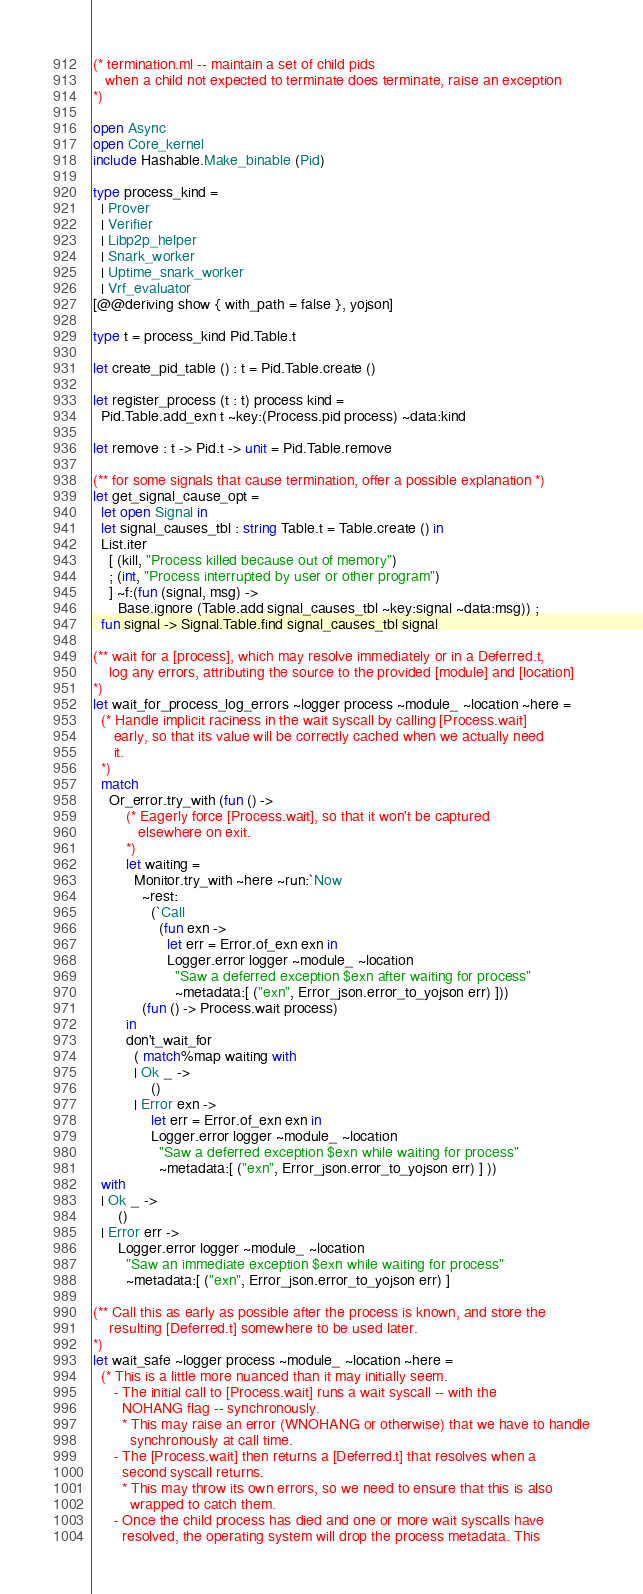Convert code to text. <code><loc_0><loc_0><loc_500><loc_500><_OCaml_>(* termination.ml -- maintain a set of child pids
   when a child not expected to terminate does terminate, raise an exception
*)

open Async
open Core_kernel
include Hashable.Make_binable (Pid)

type process_kind =
  | Prover
  | Verifier
  | Libp2p_helper
  | Snark_worker
  | Uptime_snark_worker
  | Vrf_evaluator
[@@deriving show { with_path = false }, yojson]

type t = process_kind Pid.Table.t

let create_pid_table () : t = Pid.Table.create ()

let register_process (t : t) process kind =
  Pid.Table.add_exn t ~key:(Process.pid process) ~data:kind

let remove : t -> Pid.t -> unit = Pid.Table.remove

(** for some signals that cause termination, offer a possible explanation *)
let get_signal_cause_opt =
  let open Signal in
  let signal_causes_tbl : string Table.t = Table.create () in
  List.iter
    [ (kill, "Process killed because out of memory")
    ; (int, "Process interrupted by user or other program")
    ] ~f:(fun (signal, msg) ->
      Base.ignore (Table.add signal_causes_tbl ~key:signal ~data:msg)) ;
  fun signal -> Signal.Table.find signal_causes_tbl signal

(** wait for a [process], which may resolve immediately or in a Deferred.t,
    log any errors, attributing the source to the provided [module] and [location]
*)
let wait_for_process_log_errors ~logger process ~module_ ~location ~here =
  (* Handle implicit raciness in the wait syscall by calling [Process.wait]
     early, so that its value will be correctly cached when we actually need
     it.
  *)
  match
    Or_error.try_with (fun () ->
        (* Eagerly force [Process.wait], so that it won't be captured
           elsewhere on exit.
        *)
        let waiting =
          Monitor.try_with ~here ~run:`Now
            ~rest:
              (`Call
                (fun exn ->
                  let err = Error.of_exn exn in
                  Logger.error logger ~module_ ~location
                    "Saw a deferred exception $exn after waiting for process"
                    ~metadata:[ ("exn", Error_json.error_to_yojson err) ]))
            (fun () -> Process.wait process)
        in
        don't_wait_for
          ( match%map waiting with
          | Ok _ ->
              ()
          | Error exn ->
              let err = Error.of_exn exn in
              Logger.error logger ~module_ ~location
                "Saw a deferred exception $exn while waiting for process"
                ~metadata:[ ("exn", Error_json.error_to_yojson err) ] ))
  with
  | Ok _ ->
      ()
  | Error err ->
      Logger.error logger ~module_ ~location
        "Saw an immediate exception $exn while waiting for process"
        ~metadata:[ ("exn", Error_json.error_to_yojson err) ]

(** Call this as early as possible after the process is known, and store the
    resulting [Deferred.t] somewhere to be used later.
*)
let wait_safe ~logger process ~module_ ~location ~here =
  (* This is a little more nuanced than it may initially seem.
     - The initial call to [Process.wait] runs a wait syscall -- with the
       NOHANG flag -- synchronously.
       * This may raise an error (WNOHANG or otherwise) that we have to handle
         synchronously at call time.
     - The [Process.wait] then returns a [Deferred.t] that resolves when a
       second syscall returns.
       * This may throw its own errors, so we need to ensure that this is also
         wrapped to catch them.
     - Once the child process has died and one or more wait syscalls have
       resolved, the operating system will drop the process metadata. This</code> 